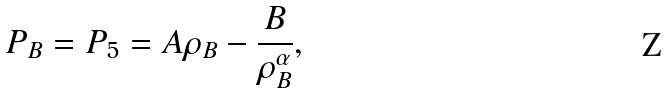Convert formula to latex. <formula><loc_0><loc_0><loc_500><loc_500>P _ { B } = P _ { 5 } = A \rho _ { B } - \frac { B } { \rho _ { B } ^ { \alpha } } ,</formula> 